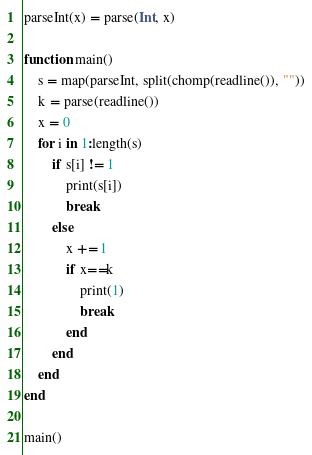Convert code to text. <code><loc_0><loc_0><loc_500><loc_500><_Julia_>parseInt(x) = parse(Int, x)

function main()
	s = map(parseInt, split(chomp(readline()), ""))
	k = parse(readline())
	x = 0
	for i in 1:length(s)
		if s[i] != 1
			print(s[i])
			break
		else
			x += 1
			if x==k
				print(1)
				break
			end
		end
	end
end

main()</code> 